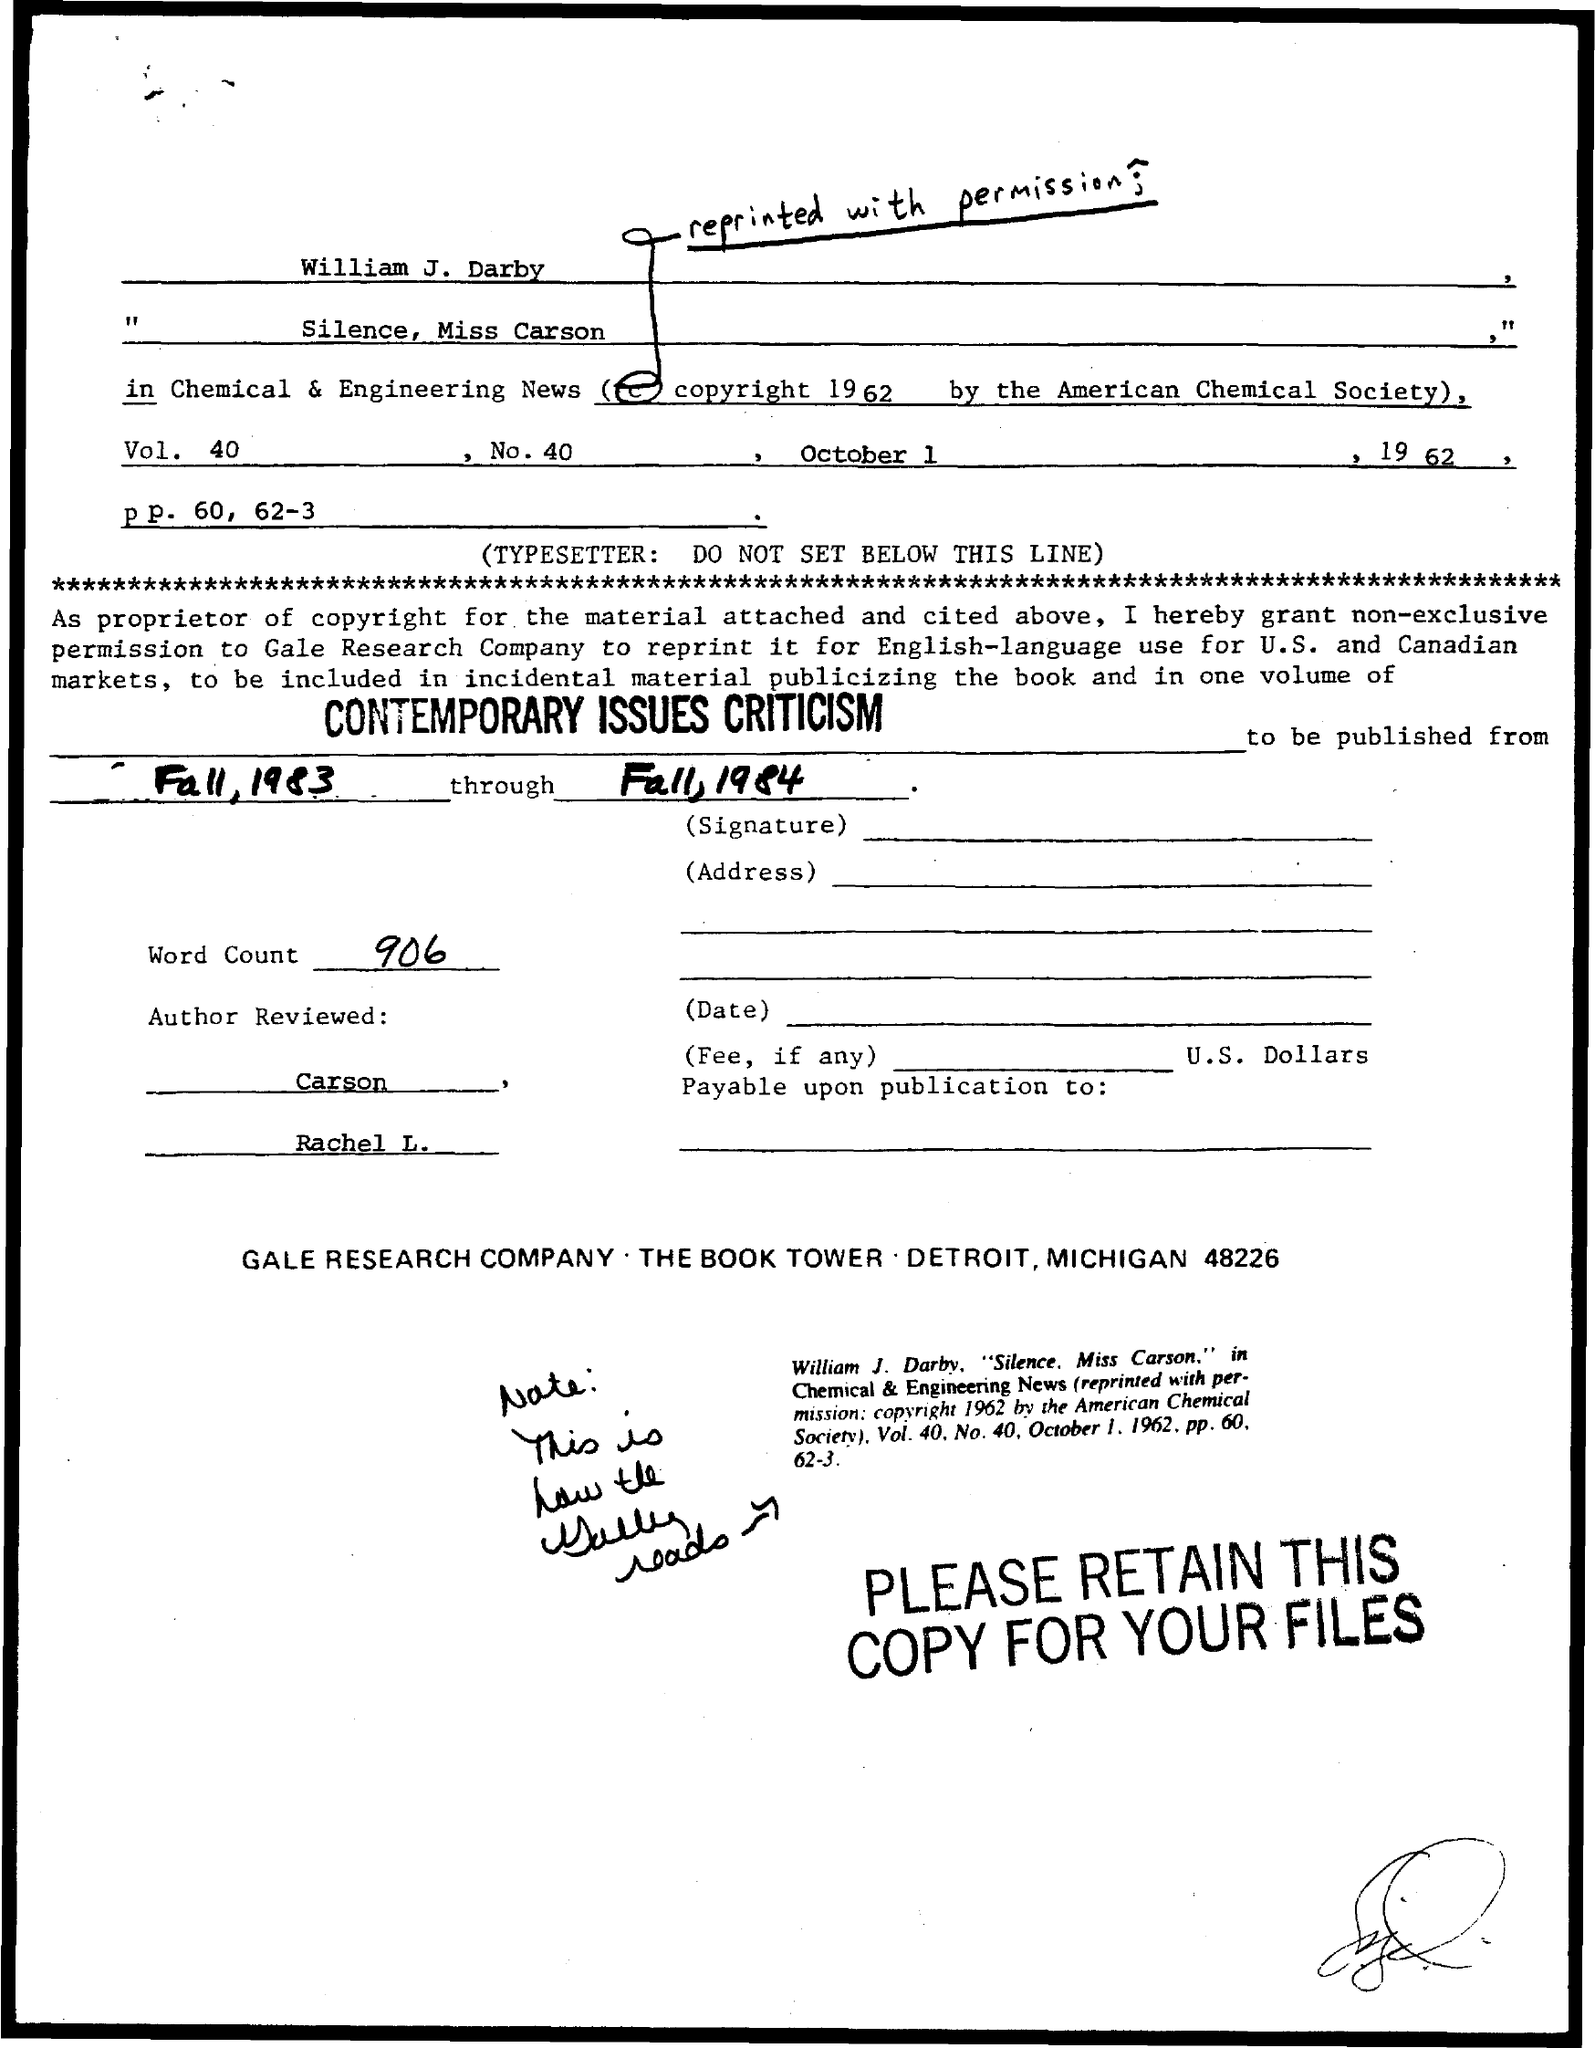What is the name of society who had the copyright?
Keep it short and to the point. American Chemical Society. Who got the permission to reprint?
Make the answer very short. Gale research company. How many word were counted?
Provide a short and direct response. 906. 